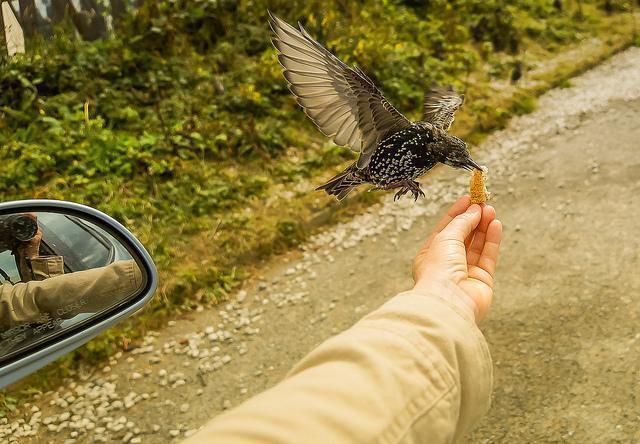What is the man doing to the bird?
Make your selection from the four choices given to correctly answer the question.
Options: Injuring it, feeding it, capturing it, hunting it. Feeding it. 